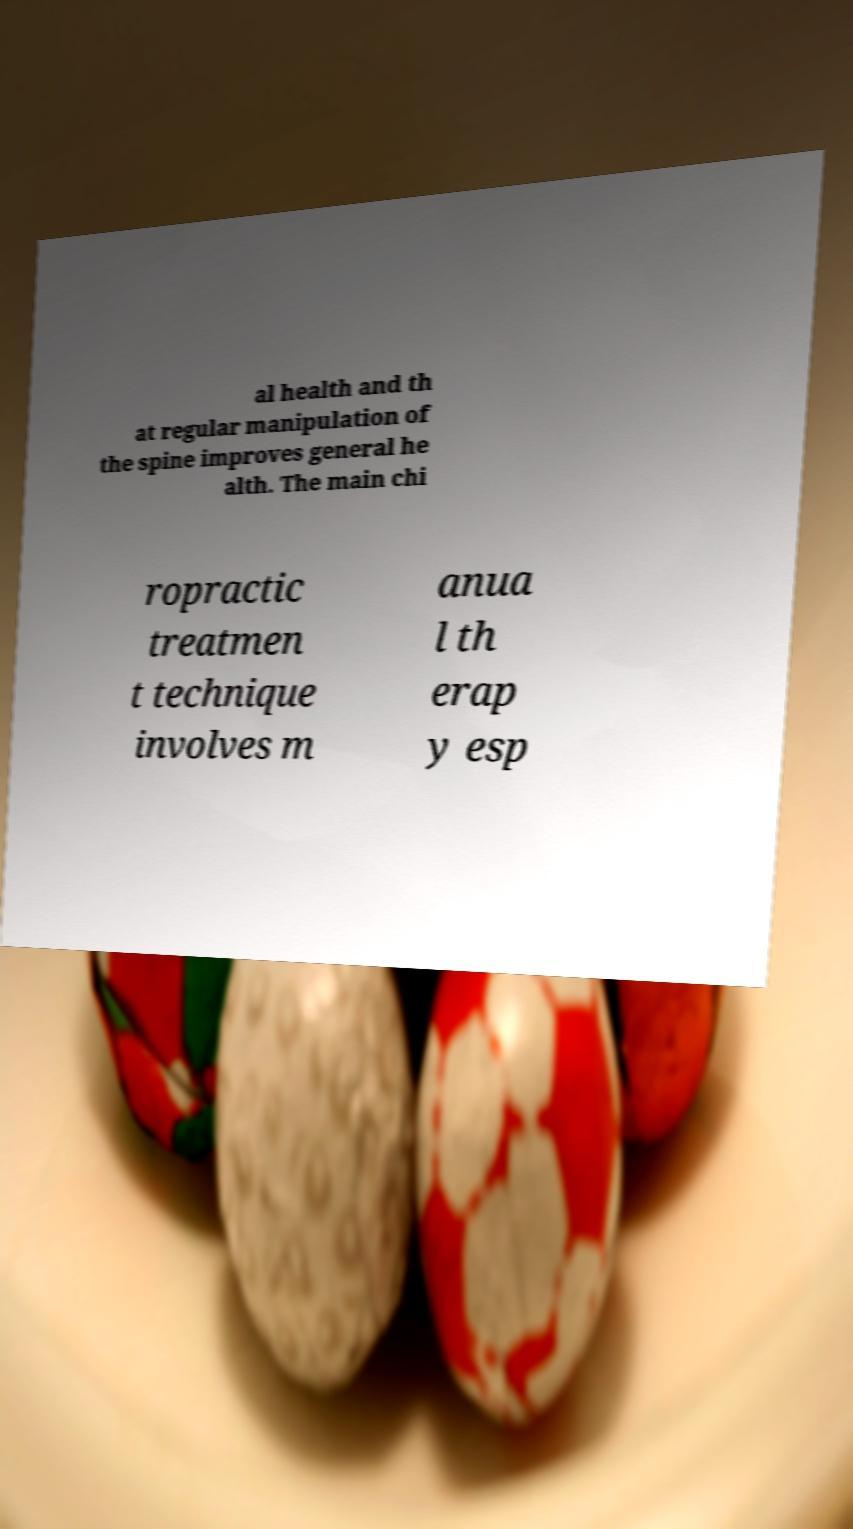Can you read and provide the text displayed in the image?This photo seems to have some interesting text. Can you extract and type it out for me? al health and th at regular manipulation of the spine improves general he alth. The main chi ropractic treatmen t technique involves m anua l th erap y esp 